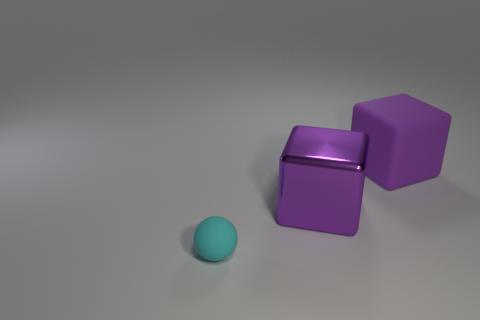Add 2 big red blocks. How many objects exist? 5 Subtract all cubes. How many objects are left? 1 Add 2 tiny cyan objects. How many tiny cyan objects are left? 3 Add 3 brown blocks. How many brown blocks exist? 3 Subtract 0 yellow cylinders. How many objects are left? 3 Subtract all green metal cubes. Subtract all tiny rubber balls. How many objects are left? 2 